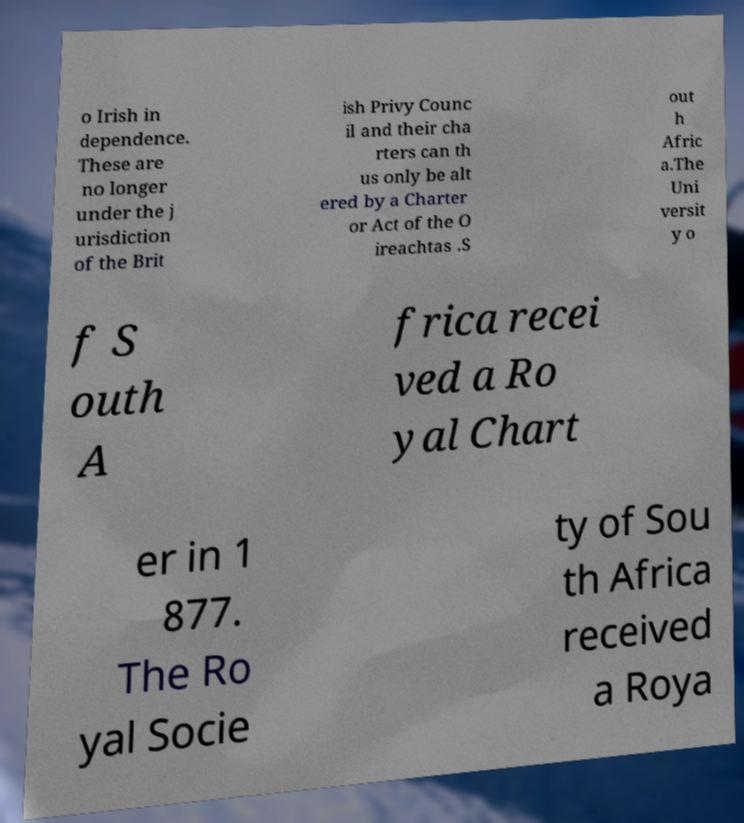Please identify and transcribe the text found in this image. o Irish in dependence. These are no longer under the j urisdiction of the Brit ish Privy Counc il and their cha rters can th us only be alt ered by a Charter or Act of the O ireachtas .S out h Afric a.The Uni versit y o f S outh A frica recei ved a Ro yal Chart er in 1 877. The Ro yal Socie ty of Sou th Africa received a Roya 